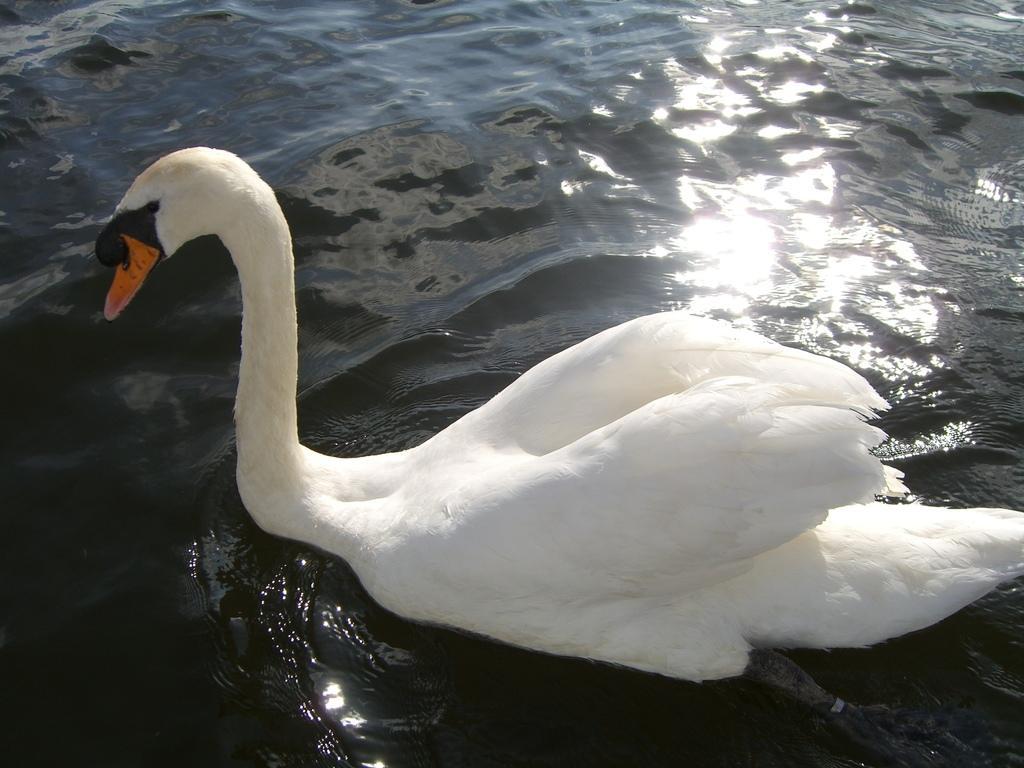Describe this image in one or two sentences. In this image we can see a swan on the water. 